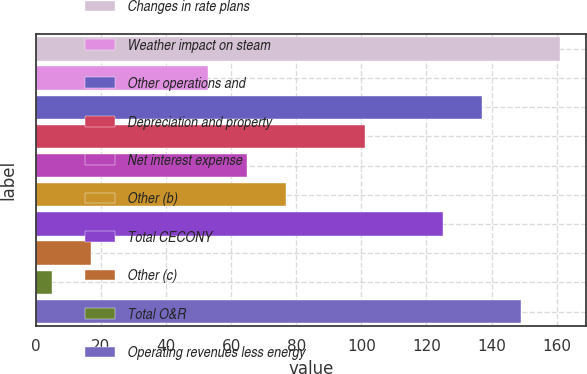Convert chart. <chart><loc_0><loc_0><loc_500><loc_500><bar_chart><fcel>Changes in rate plans<fcel>Weather impact on steam<fcel>Other operations and<fcel>Depreciation and property<fcel>Net interest expense<fcel>Other (b)<fcel>Total CECONY<fcel>Other (c)<fcel>Total O&R<fcel>Operating revenues less energy<nl><fcel>161<fcel>53<fcel>137<fcel>101<fcel>65<fcel>77<fcel>125<fcel>17<fcel>5<fcel>149<nl></chart> 